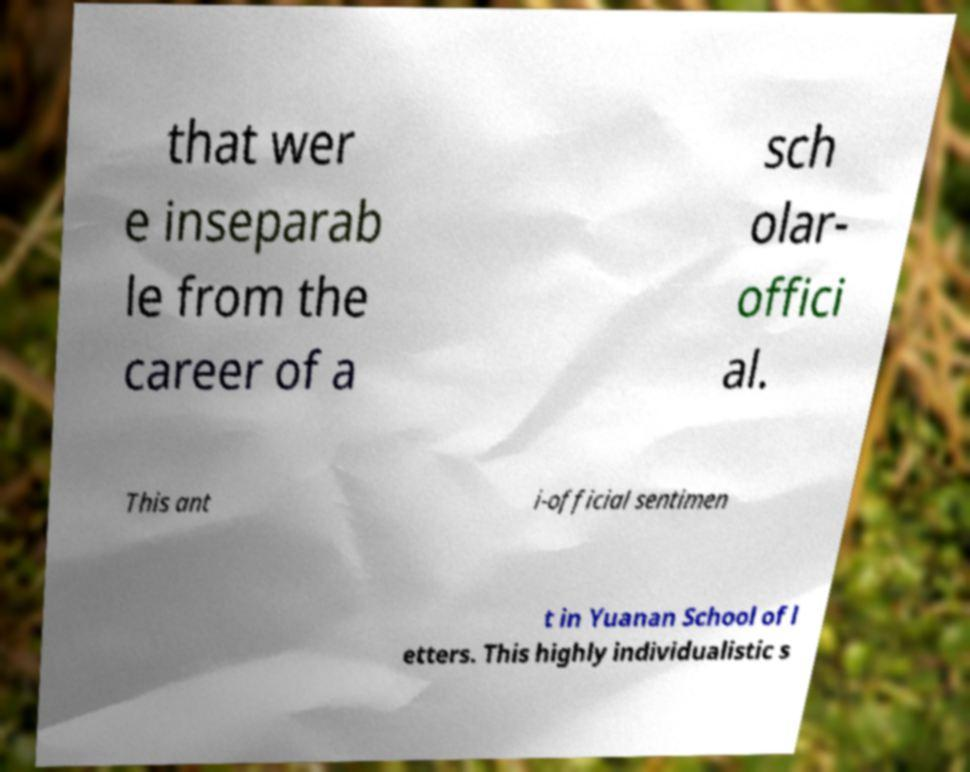For documentation purposes, I need the text within this image transcribed. Could you provide that? that wer e inseparab le from the career of a sch olar- offici al. This ant i-official sentimen t in Yuanan School of l etters. This highly individualistic s 